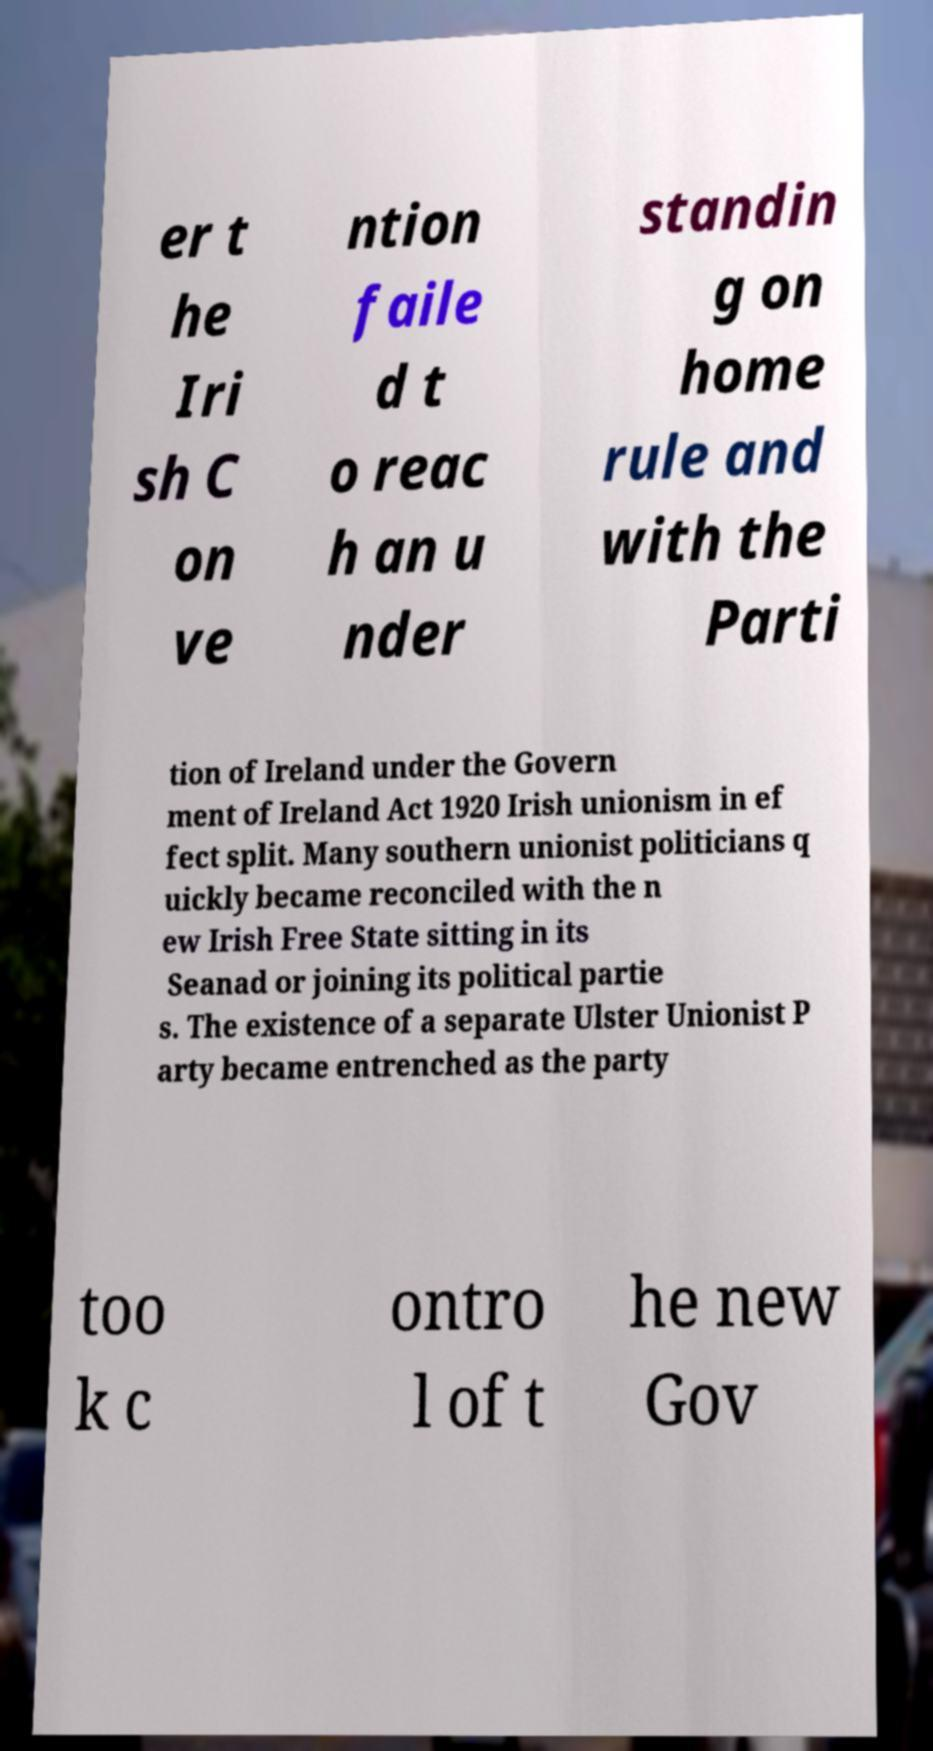Could you assist in decoding the text presented in this image and type it out clearly? er t he Iri sh C on ve ntion faile d t o reac h an u nder standin g on home rule and with the Parti tion of Ireland under the Govern ment of Ireland Act 1920 Irish unionism in ef fect split. Many southern unionist politicians q uickly became reconciled with the n ew Irish Free State sitting in its Seanad or joining its political partie s. The existence of a separate Ulster Unionist P arty became entrenched as the party too k c ontro l of t he new Gov 